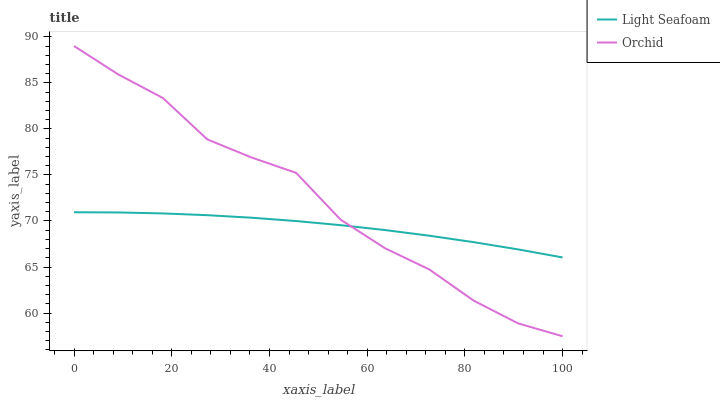Does Light Seafoam have the minimum area under the curve?
Answer yes or no. Yes. Does Orchid have the maximum area under the curve?
Answer yes or no. Yes. Does Orchid have the minimum area under the curve?
Answer yes or no. No. Is Light Seafoam the smoothest?
Answer yes or no. Yes. Is Orchid the roughest?
Answer yes or no. Yes. Is Orchid the smoothest?
Answer yes or no. No. Does Orchid have the lowest value?
Answer yes or no. Yes. Does Orchid have the highest value?
Answer yes or no. Yes. Does Orchid intersect Light Seafoam?
Answer yes or no. Yes. Is Orchid less than Light Seafoam?
Answer yes or no. No. Is Orchid greater than Light Seafoam?
Answer yes or no. No. 